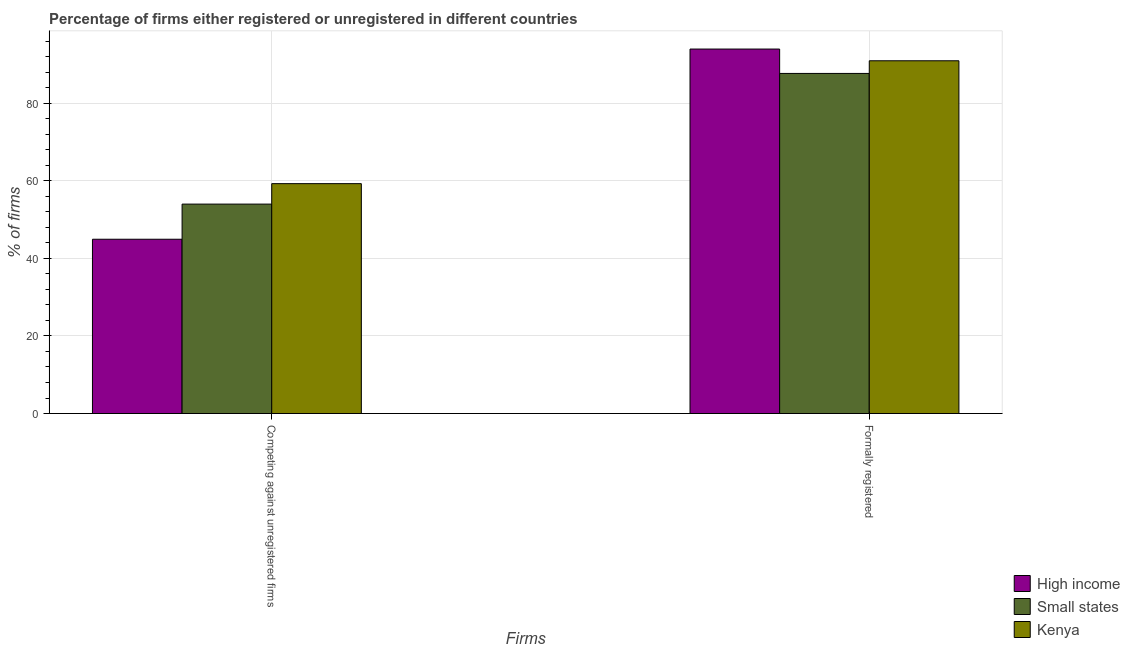How many bars are there on the 2nd tick from the left?
Provide a succinct answer. 3. What is the label of the 1st group of bars from the left?
Ensure brevity in your answer.  Competing against unregistered firms. What is the percentage of formally registered firms in Kenya?
Offer a terse response. 91. Across all countries, what is the maximum percentage of formally registered firms?
Provide a short and direct response. 94.03. Across all countries, what is the minimum percentage of registered firms?
Your answer should be compact. 44.96. In which country was the percentage of formally registered firms maximum?
Offer a terse response. High income. In which country was the percentage of registered firms minimum?
Provide a succinct answer. High income. What is the total percentage of formally registered firms in the graph?
Ensure brevity in your answer.  272.76. What is the difference between the percentage of formally registered firms in Small states and that in Kenya?
Your answer should be compact. -3.26. What is the difference between the percentage of formally registered firms in High income and the percentage of registered firms in Kenya?
Provide a short and direct response. 34.73. What is the average percentage of registered firms per country?
Make the answer very short. 52.76. What is the difference between the percentage of formally registered firms and percentage of registered firms in Kenya?
Provide a succinct answer. 31.7. What is the ratio of the percentage of registered firms in Kenya to that in Small states?
Your response must be concise. 1.1. What does the 2nd bar from the left in Formally registered represents?
Ensure brevity in your answer.  Small states. What does the 2nd bar from the right in Formally registered represents?
Your answer should be compact. Small states. How many bars are there?
Offer a very short reply. 6. Are the values on the major ticks of Y-axis written in scientific E-notation?
Offer a terse response. No. Does the graph contain any zero values?
Offer a terse response. No. Does the graph contain grids?
Offer a terse response. Yes. How are the legend labels stacked?
Make the answer very short. Vertical. What is the title of the graph?
Offer a terse response. Percentage of firms either registered or unregistered in different countries. What is the label or title of the X-axis?
Your answer should be very brief. Firms. What is the label or title of the Y-axis?
Provide a short and direct response. % of firms. What is the % of firms in High income in Competing against unregistered firms?
Your answer should be compact. 44.96. What is the % of firms in Small states in Competing against unregistered firms?
Provide a succinct answer. 54.02. What is the % of firms of Kenya in Competing against unregistered firms?
Keep it short and to the point. 59.3. What is the % of firms in High income in Formally registered?
Offer a very short reply. 94.03. What is the % of firms in Small states in Formally registered?
Keep it short and to the point. 87.74. What is the % of firms in Kenya in Formally registered?
Your response must be concise. 91. Across all Firms, what is the maximum % of firms in High income?
Your response must be concise. 94.03. Across all Firms, what is the maximum % of firms of Small states?
Ensure brevity in your answer.  87.74. Across all Firms, what is the maximum % of firms of Kenya?
Your answer should be very brief. 91. Across all Firms, what is the minimum % of firms in High income?
Your answer should be compact. 44.96. Across all Firms, what is the minimum % of firms of Small states?
Provide a succinct answer. 54.02. Across all Firms, what is the minimum % of firms in Kenya?
Ensure brevity in your answer.  59.3. What is the total % of firms of High income in the graph?
Give a very brief answer. 138.98. What is the total % of firms of Small states in the graph?
Your answer should be compact. 141.76. What is the total % of firms in Kenya in the graph?
Give a very brief answer. 150.3. What is the difference between the % of firms in High income in Competing against unregistered firms and that in Formally registered?
Your answer should be very brief. -49.07. What is the difference between the % of firms of Small states in Competing against unregistered firms and that in Formally registered?
Your response must be concise. -33.71. What is the difference between the % of firms of Kenya in Competing against unregistered firms and that in Formally registered?
Ensure brevity in your answer.  -31.7. What is the difference between the % of firms in High income in Competing against unregistered firms and the % of firms in Small states in Formally registered?
Your answer should be compact. -42.78. What is the difference between the % of firms of High income in Competing against unregistered firms and the % of firms of Kenya in Formally registered?
Your response must be concise. -46.04. What is the difference between the % of firms of Small states in Competing against unregistered firms and the % of firms of Kenya in Formally registered?
Your response must be concise. -36.98. What is the average % of firms in High income per Firms?
Your response must be concise. 69.49. What is the average % of firms in Small states per Firms?
Your response must be concise. 70.88. What is the average % of firms in Kenya per Firms?
Your answer should be compact. 75.15. What is the difference between the % of firms of High income and % of firms of Small states in Competing against unregistered firms?
Provide a succinct answer. -9.06. What is the difference between the % of firms in High income and % of firms in Kenya in Competing against unregistered firms?
Ensure brevity in your answer.  -14.34. What is the difference between the % of firms in Small states and % of firms in Kenya in Competing against unregistered firms?
Offer a terse response. -5.28. What is the difference between the % of firms of High income and % of firms of Small states in Formally registered?
Give a very brief answer. 6.29. What is the difference between the % of firms in High income and % of firms in Kenya in Formally registered?
Keep it short and to the point. 3.02. What is the difference between the % of firms of Small states and % of firms of Kenya in Formally registered?
Ensure brevity in your answer.  -3.26. What is the ratio of the % of firms in High income in Competing against unregistered firms to that in Formally registered?
Your answer should be very brief. 0.48. What is the ratio of the % of firms in Small states in Competing against unregistered firms to that in Formally registered?
Offer a very short reply. 0.62. What is the ratio of the % of firms in Kenya in Competing against unregistered firms to that in Formally registered?
Offer a very short reply. 0.65. What is the difference between the highest and the second highest % of firms of High income?
Provide a succinct answer. 49.07. What is the difference between the highest and the second highest % of firms in Small states?
Offer a very short reply. 33.71. What is the difference between the highest and the second highest % of firms of Kenya?
Your answer should be compact. 31.7. What is the difference between the highest and the lowest % of firms in High income?
Offer a terse response. 49.07. What is the difference between the highest and the lowest % of firms in Small states?
Make the answer very short. 33.71. What is the difference between the highest and the lowest % of firms in Kenya?
Make the answer very short. 31.7. 